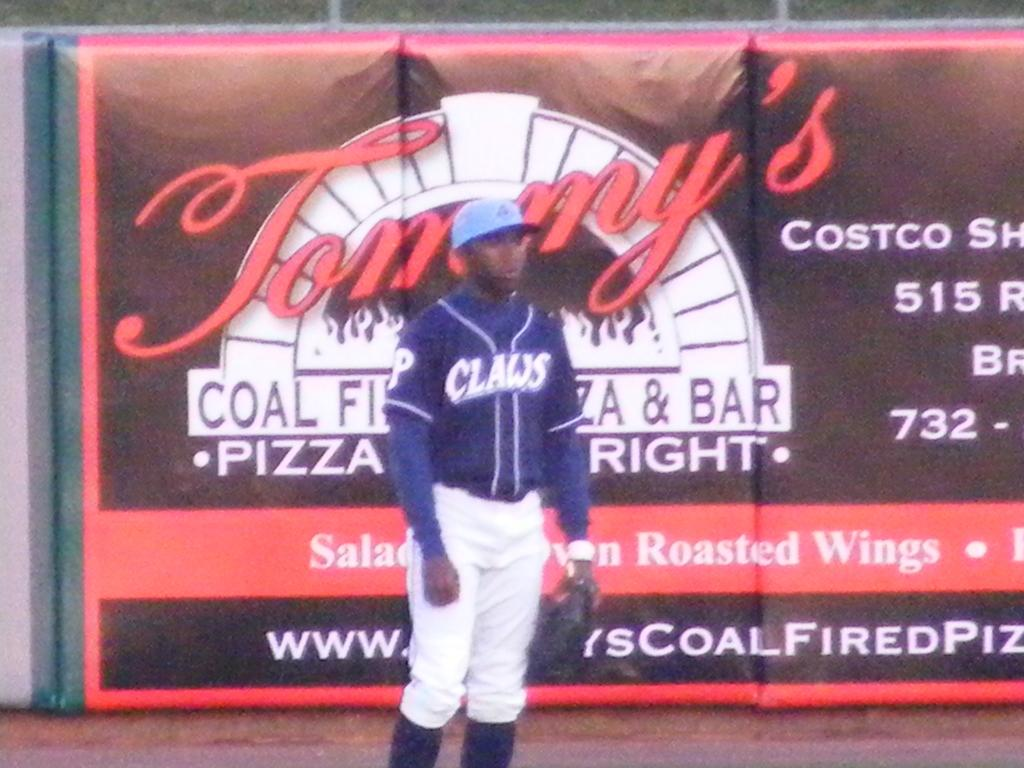<image>
Write a terse but informative summary of the picture. Baseball player standing in front of Tommy's coal fire oven pizza and bar sign. 